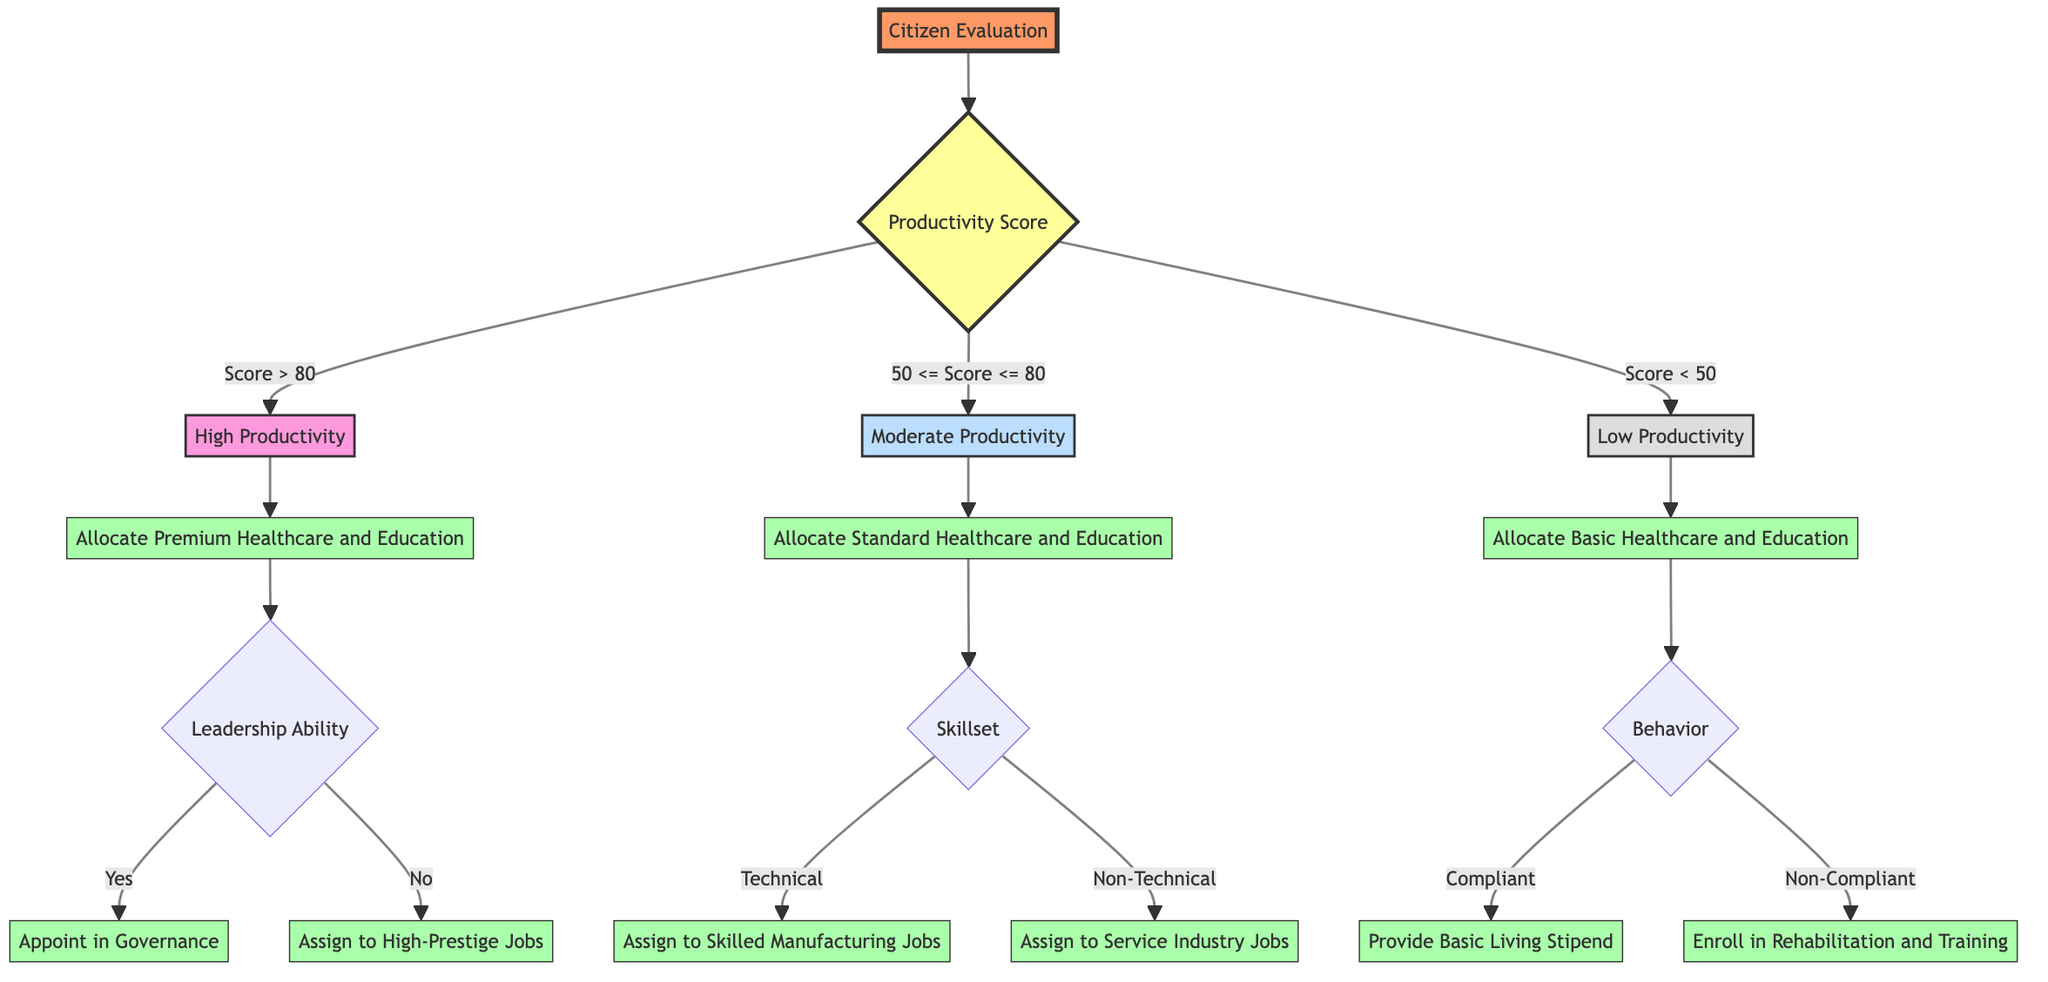What is the root node of the decision tree? The root node of the decision tree is labeled "Citizen Evaluation," which is the starting point for evaluating citizens based on their productivity scores.
Answer: Citizen Evaluation How many branches does the "Productivity Score" node have? The "Productivity Score" node has three branches, representing the different score ranges: Score > 80, 50 <= Score <= 80, and Score < 50.
Answer: 3 What action is taken for a citizen with a productivity score greater than 80? For a citizen with a productivity score greater than 80, the action is to "Allocate Premium Healthcare and Education." This indicates a high level of resources for highly productive individuals.
Answer: Allocate Premium Healthcare and Education If a citizen has a productivity score between 50 and 80 and possesses a technical skillset, what is the employment allocation? If a citizen has a productivity score between 50 and 80 and is identified as a technical worker, the employment allocation is "Assign to Skilled Manufacturing Jobs," showing the specific job sector for this group.
Answer: Assign to Skilled Manufacturing Jobs What is the outcome for a citizen classified as Non-Compliant? A Non-Compliant citizen will be enrolled in "Rehabilitation and Training," indicating a corrective approach for citizens who do not adhere to societal norms.
Answer: Enroll in Rehabilitation and Training What type of healthcare is allocated to citizens with a productivity score less than 50? Citizens with a productivity score less than 50 are allocated "Basic Healthcare and Education," which reflects the minimal level of resources provided to this group.
Answer: Basic Healthcare and Education How is a citizen with a productivity score greater than 80 and leadership ability classified? A citizen with a productivity score greater than 80 and identified as having leadership ability is classified as a "Leader," indicating a position of authority within governance.
Answer: Leader What resource type is provided for citizens with moderate productivity scores? Citizens with moderate productivity scores are provided with "Standard" resource types for healthcare and education, illustrating a middle-tier allocation.
Answer: Standard What action does the system recommend for a compliant citizen with low productivity? The system recommends providing a "Basic Living Stipend" for compliant citizens with low productivity scores, ensuring basic financial support for compliance.
Answer: Provide Basic Living Stipend 